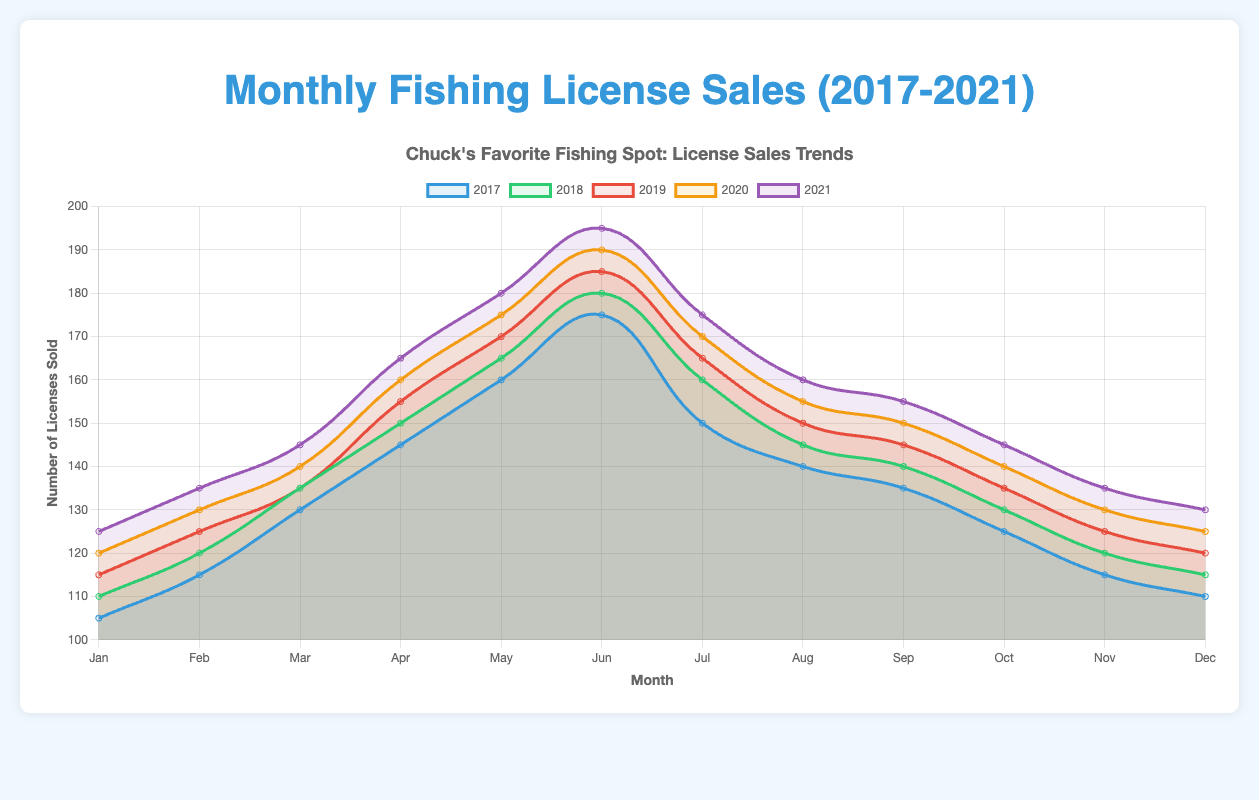Which year had the highest number of fishing licenses sold in June? To determine the year with the highest sales in June, check the fishing license sales for June in each year. The values are: 2017 (175), 2018 (180), 2019 (185), 2020 (190), 2021 (195). Therefore, 2021 had the highest number of fishing licenses sold in June.
Answer: 2021 How did fishing license sales in May 2021 compare to May 2017? Compare the sales of fishing licenses in May for 2021 and 2017. The values are 180 for 2021 and 160 for 2017. By simple comparison, May 2021 had higher sales than May 2017.
Answer: May 2021 had higher sales Which month consistently had the lowest sales across all five years? Check the sales data for each month across all five years and identify the month with the consistently lowest sales. January had increasing sales each year, whereas December consistently had lower sales relative to other months, with the values for December being 2017 (110), 2018 (115), 2019 (120), 2020 (125), 2021 (130). December consistently had the lowest sales.
Answer: December Which year showed the steepest increase in sales from February to March? To determine the steepest increase, calculate the difference between March and February sales for each year. 2017: 130 - 115 = 15, 2018: 135 - 120 = 15, 2019: 135 - 125 = 10, 2020: 140 - 130 = 10, 2021: 145 - 135 = 10. Both 2017 and 2018 had the steepest increases of 15 licenses.
Answer: 2017 and 2018 What is the average number of licenses sold in August across all five years? Sum the number of licenses sold in August for each year and divide by 5. The values are 140 (2017), 145 (2018), 150 (2019), 155 (2020), 160 (2021). Sum: 140+145+150+155+160 = 750. Average: 750/5 = 150.
Answer: 150 What is the difference in fishing license sales between January 2017 and January 2021? Subtract the number of sales in January 2017 from those in January 2021. Values: 2021 (125) - 2017 (105). The difference is 125 - 105 = 20.
Answer: 20 Which year had the most stable sales pattern (least fluctuation) from month to month? To determine this, observe the changes in monthly sales within each year. Comparing the values visually, 2019 and 2020 appear relatively stable with fewer sharp changes compared to other years. For a precise answer, calculating the standard deviation of monthly sales for each year would be ideal, but based on visual inspection alone, choose 2019 or 2020, which showed less variability.
Answer: 2019 and 2020 (most stable pattern) 